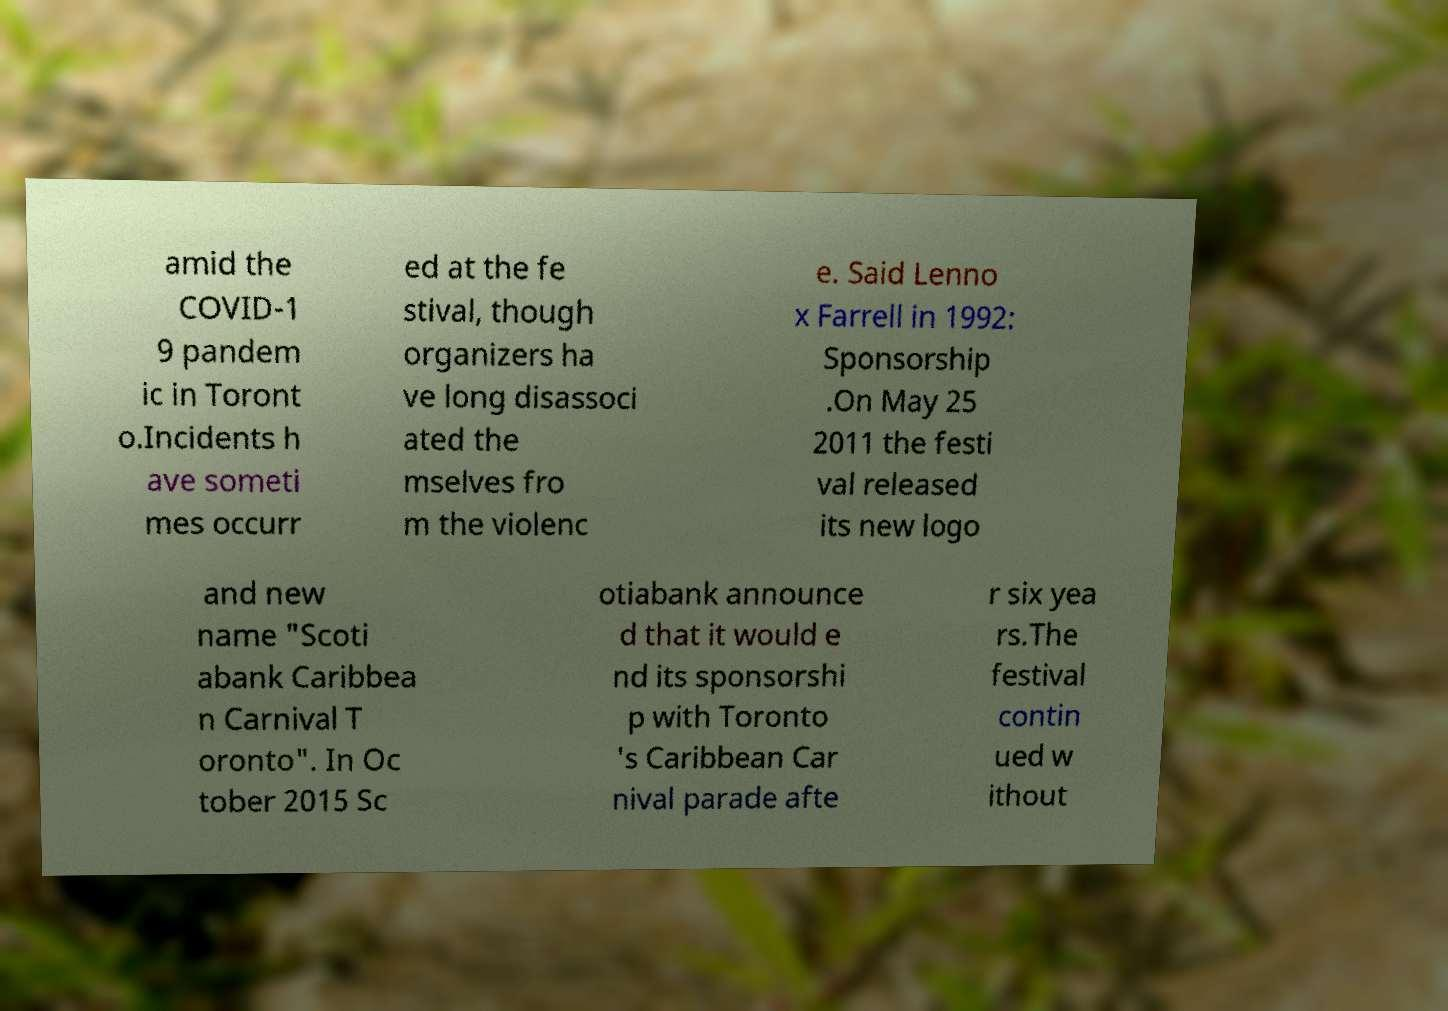Can you accurately transcribe the text from the provided image for me? amid the COVID-1 9 pandem ic in Toront o.Incidents h ave someti mes occurr ed at the fe stival, though organizers ha ve long disassoci ated the mselves fro m the violenc e. Said Lenno x Farrell in 1992: Sponsorship .On May 25 2011 the festi val released its new logo and new name "Scoti abank Caribbea n Carnival T oronto". In Oc tober 2015 Sc otiabank announce d that it would e nd its sponsorshi p with Toronto 's Caribbean Car nival parade afte r six yea rs.The festival contin ued w ithout 